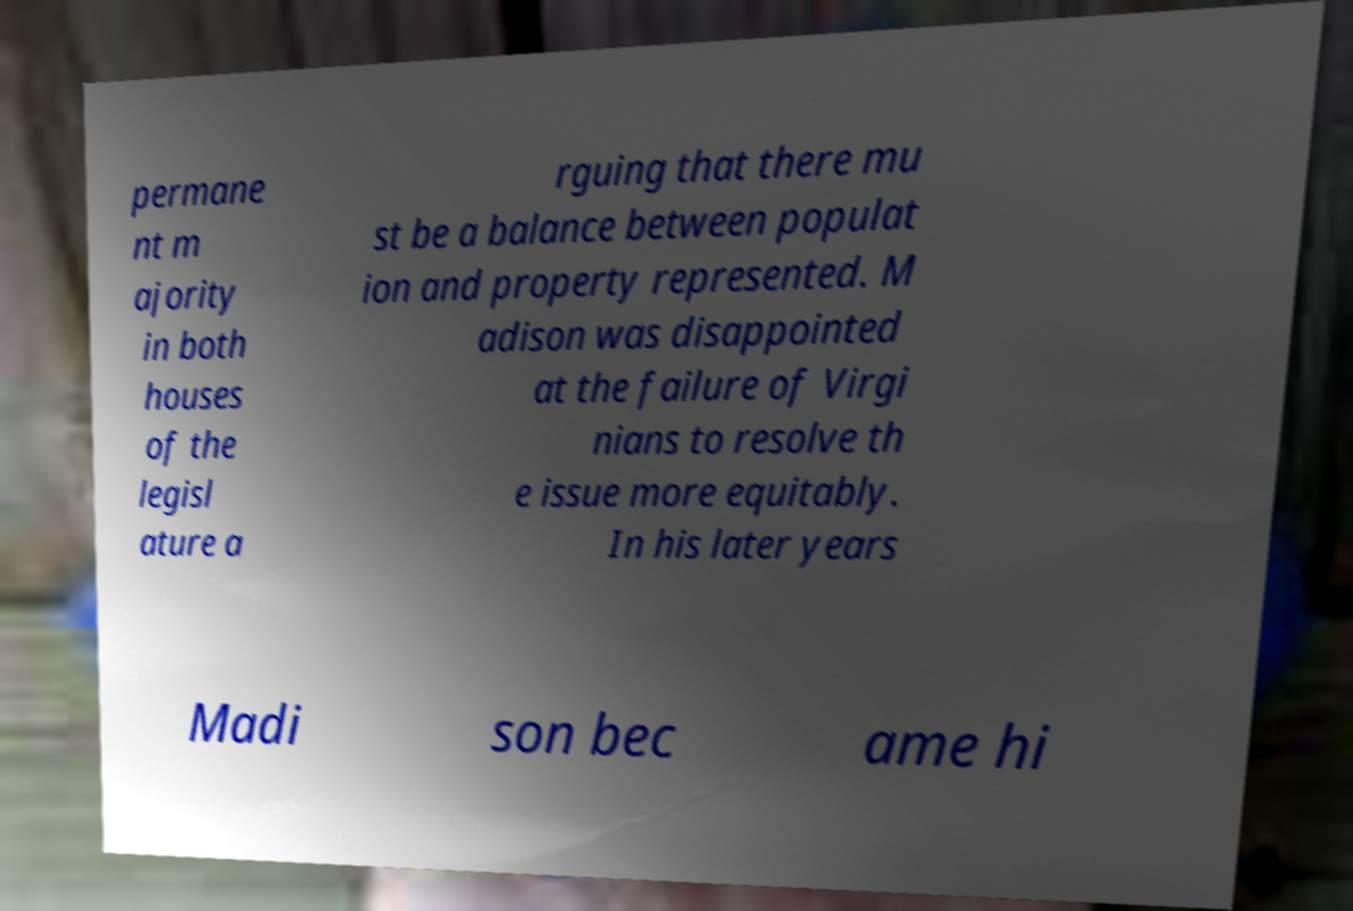Could you assist in decoding the text presented in this image and type it out clearly? permane nt m ajority in both houses of the legisl ature a rguing that there mu st be a balance between populat ion and property represented. M adison was disappointed at the failure of Virgi nians to resolve th e issue more equitably. In his later years Madi son bec ame hi 